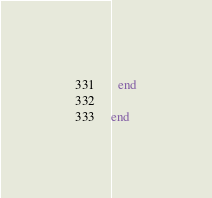Convert code to text. <code><loc_0><loc_0><loc_500><loc_500><_Ruby_>  end

end
</code> 